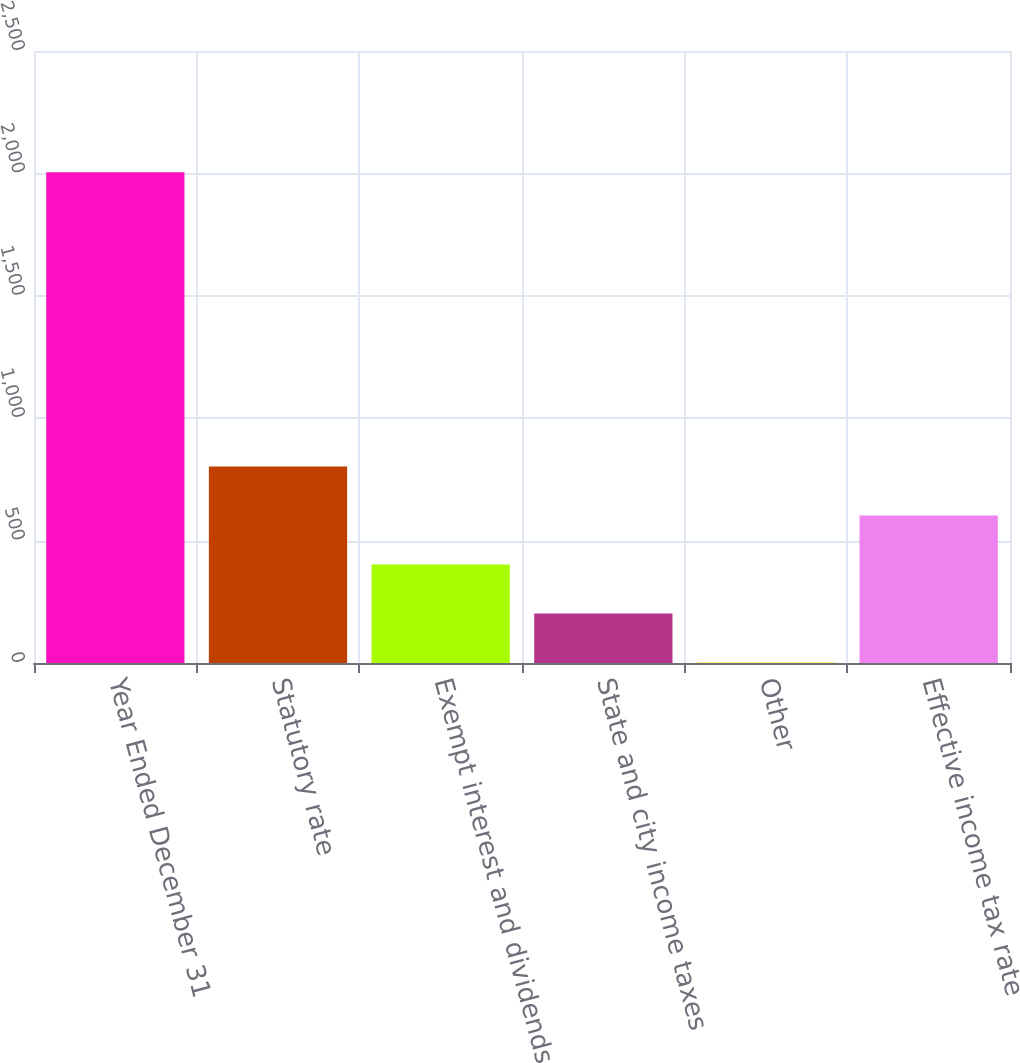Convert chart. <chart><loc_0><loc_0><loc_500><loc_500><bar_chart><fcel>Year Ended December 31<fcel>Statutory rate<fcel>Exempt interest and dividends<fcel>State and city income taxes<fcel>Other<fcel>Effective income tax rate<nl><fcel>2005<fcel>803.2<fcel>402.6<fcel>202.3<fcel>2<fcel>602.9<nl></chart> 